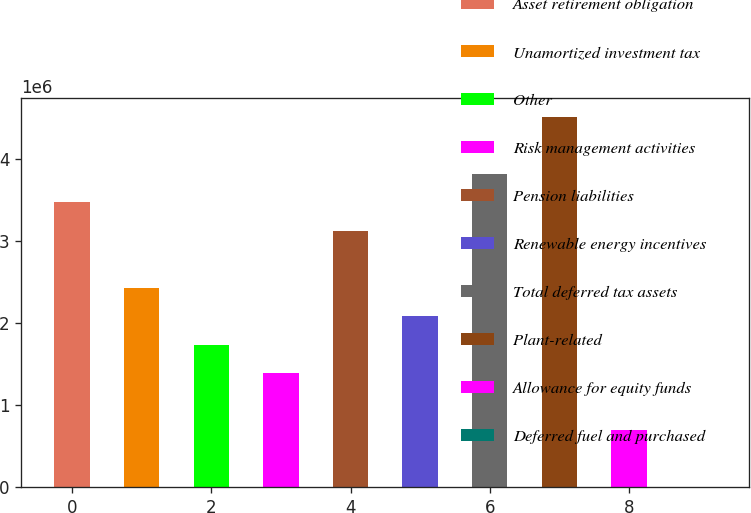<chart> <loc_0><loc_0><loc_500><loc_500><bar_chart><fcel>Asset retirement obligation<fcel>Unamortized investment tax<fcel>Other<fcel>Risk management activities<fcel>Pension liabilities<fcel>Renewable energy incentives<fcel>Total deferred tax assets<fcel>Plant-related<fcel>Allowance for equity funds<fcel>Deferred fuel and purchased<nl><fcel>3.47162e+06<fcel>2.43088e+06<fcel>1.73706e+06<fcel>1.39014e+06<fcel>3.1247e+06<fcel>2.08397e+06<fcel>3.81853e+06<fcel>4.51235e+06<fcel>696321<fcel>2498<nl></chart> 